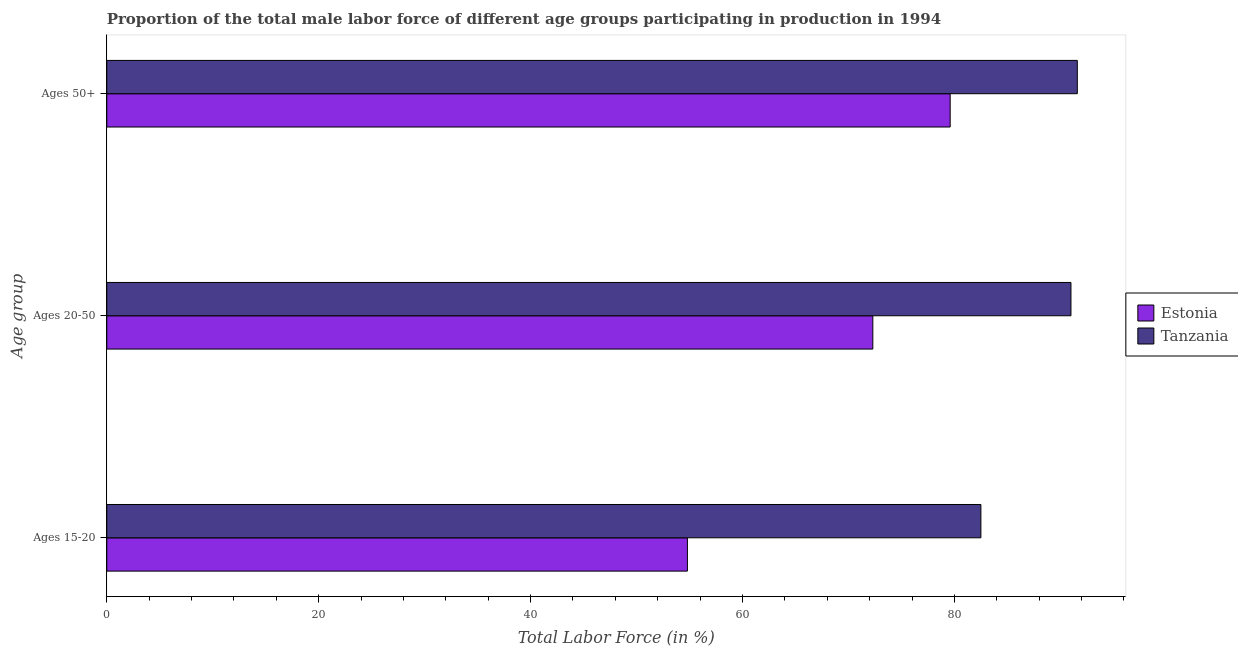How many groups of bars are there?
Ensure brevity in your answer.  3. What is the label of the 2nd group of bars from the top?
Make the answer very short. Ages 20-50. What is the percentage of male labor force within the age group 20-50 in Estonia?
Keep it short and to the point. 72.3. Across all countries, what is the maximum percentage of male labor force within the age group 15-20?
Your response must be concise. 82.5. Across all countries, what is the minimum percentage of male labor force within the age group 20-50?
Offer a terse response. 72.3. In which country was the percentage of male labor force above age 50 maximum?
Your response must be concise. Tanzania. In which country was the percentage of male labor force within the age group 15-20 minimum?
Give a very brief answer. Estonia. What is the total percentage of male labor force within the age group 15-20 in the graph?
Ensure brevity in your answer.  137.3. What is the difference between the percentage of male labor force within the age group 20-50 in Estonia and that in Tanzania?
Your answer should be very brief. -18.7. What is the difference between the percentage of male labor force above age 50 in Estonia and the percentage of male labor force within the age group 20-50 in Tanzania?
Ensure brevity in your answer.  -11.4. What is the average percentage of male labor force within the age group 20-50 per country?
Provide a short and direct response. 81.65. What is the difference between the percentage of male labor force within the age group 20-50 and percentage of male labor force within the age group 15-20 in Estonia?
Make the answer very short. 17.5. In how many countries, is the percentage of male labor force within the age group 15-20 greater than 48 %?
Your answer should be compact. 2. What is the ratio of the percentage of male labor force within the age group 20-50 in Tanzania to that in Estonia?
Your answer should be compact. 1.26. Is the percentage of male labor force within the age group 15-20 in Tanzania less than that in Estonia?
Provide a succinct answer. No. What is the difference between the highest and the second highest percentage of male labor force within the age group 15-20?
Offer a very short reply. 27.7. What is the difference between the highest and the lowest percentage of male labor force within the age group 20-50?
Your response must be concise. 18.7. In how many countries, is the percentage of male labor force within the age group 20-50 greater than the average percentage of male labor force within the age group 20-50 taken over all countries?
Ensure brevity in your answer.  1. Is the sum of the percentage of male labor force within the age group 20-50 in Tanzania and Estonia greater than the maximum percentage of male labor force within the age group 15-20 across all countries?
Your answer should be very brief. Yes. What does the 1st bar from the top in Ages 15-20 represents?
Offer a very short reply. Tanzania. What does the 1st bar from the bottom in Ages 15-20 represents?
Offer a terse response. Estonia. How many bars are there?
Make the answer very short. 6. Are all the bars in the graph horizontal?
Give a very brief answer. Yes. How many countries are there in the graph?
Offer a terse response. 2. What is the difference between two consecutive major ticks on the X-axis?
Keep it short and to the point. 20. Are the values on the major ticks of X-axis written in scientific E-notation?
Provide a short and direct response. No. Does the graph contain any zero values?
Ensure brevity in your answer.  No. How many legend labels are there?
Give a very brief answer. 2. How are the legend labels stacked?
Provide a succinct answer. Vertical. What is the title of the graph?
Make the answer very short. Proportion of the total male labor force of different age groups participating in production in 1994. What is the label or title of the X-axis?
Ensure brevity in your answer.  Total Labor Force (in %). What is the label or title of the Y-axis?
Your answer should be compact. Age group. What is the Total Labor Force (in %) in Estonia in Ages 15-20?
Ensure brevity in your answer.  54.8. What is the Total Labor Force (in %) in Tanzania in Ages 15-20?
Your answer should be very brief. 82.5. What is the Total Labor Force (in %) of Estonia in Ages 20-50?
Ensure brevity in your answer.  72.3. What is the Total Labor Force (in %) in Tanzania in Ages 20-50?
Make the answer very short. 91. What is the Total Labor Force (in %) of Estonia in Ages 50+?
Your response must be concise. 79.6. What is the Total Labor Force (in %) of Tanzania in Ages 50+?
Make the answer very short. 91.6. Across all Age group, what is the maximum Total Labor Force (in %) in Estonia?
Your response must be concise. 79.6. Across all Age group, what is the maximum Total Labor Force (in %) of Tanzania?
Offer a terse response. 91.6. Across all Age group, what is the minimum Total Labor Force (in %) in Estonia?
Provide a short and direct response. 54.8. Across all Age group, what is the minimum Total Labor Force (in %) of Tanzania?
Offer a very short reply. 82.5. What is the total Total Labor Force (in %) in Estonia in the graph?
Give a very brief answer. 206.7. What is the total Total Labor Force (in %) in Tanzania in the graph?
Provide a short and direct response. 265.1. What is the difference between the Total Labor Force (in %) in Estonia in Ages 15-20 and that in Ages 20-50?
Your answer should be very brief. -17.5. What is the difference between the Total Labor Force (in %) in Tanzania in Ages 15-20 and that in Ages 20-50?
Your answer should be very brief. -8.5. What is the difference between the Total Labor Force (in %) in Estonia in Ages 15-20 and that in Ages 50+?
Offer a very short reply. -24.8. What is the difference between the Total Labor Force (in %) of Estonia in Ages 20-50 and that in Ages 50+?
Provide a succinct answer. -7.3. What is the difference between the Total Labor Force (in %) of Estonia in Ages 15-20 and the Total Labor Force (in %) of Tanzania in Ages 20-50?
Your response must be concise. -36.2. What is the difference between the Total Labor Force (in %) of Estonia in Ages 15-20 and the Total Labor Force (in %) of Tanzania in Ages 50+?
Give a very brief answer. -36.8. What is the difference between the Total Labor Force (in %) of Estonia in Ages 20-50 and the Total Labor Force (in %) of Tanzania in Ages 50+?
Your response must be concise. -19.3. What is the average Total Labor Force (in %) in Estonia per Age group?
Make the answer very short. 68.9. What is the average Total Labor Force (in %) of Tanzania per Age group?
Make the answer very short. 88.37. What is the difference between the Total Labor Force (in %) in Estonia and Total Labor Force (in %) in Tanzania in Ages 15-20?
Provide a succinct answer. -27.7. What is the difference between the Total Labor Force (in %) of Estonia and Total Labor Force (in %) of Tanzania in Ages 20-50?
Your answer should be very brief. -18.7. What is the ratio of the Total Labor Force (in %) in Estonia in Ages 15-20 to that in Ages 20-50?
Offer a terse response. 0.76. What is the ratio of the Total Labor Force (in %) of Tanzania in Ages 15-20 to that in Ages 20-50?
Keep it short and to the point. 0.91. What is the ratio of the Total Labor Force (in %) of Estonia in Ages 15-20 to that in Ages 50+?
Make the answer very short. 0.69. What is the ratio of the Total Labor Force (in %) in Tanzania in Ages 15-20 to that in Ages 50+?
Provide a succinct answer. 0.9. What is the ratio of the Total Labor Force (in %) in Estonia in Ages 20-50 to that in Ages 50+?
Your answer should be very brief. 0.91. What is the difference between the highest and the second highest Total Labor Force (in %) in Estonia?
Ensure brevity in your answer.  7.3. What is the difference between the highest and the lowest Total Labor Force (in %) in Estonia?
Provide a succinct answer. 24.8. 